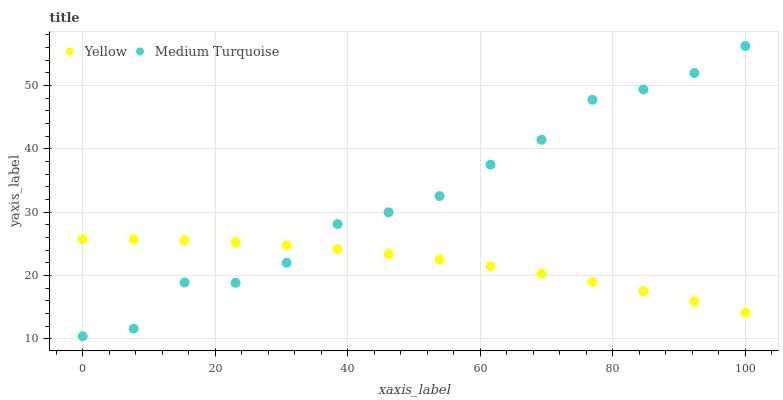Does Yellow have the minimum area under the curve?
Answer yes or no. Yes. Does Medium Turquoise have the maximum area under the curve?
Answer yes or no. Yes. Does Yellow have the maximum area under the curve?
Answer yes or no. No. Is Yellow the smoothest?
Answer yes or no. Yes. Is Medium Turquoise the roughest?
Answer yes or no. Yes. Is Yellow the roughest?
Answer yes or no. No. Does Medium Turquoise have the lowest value?
Answer yes or no. Yes. Does Yellow have the lowest value?
Answer yes or no. No. Does Medium Turquoise have the highest value?
Answer yes or no. Yes. Does Yellow have the highest value?
Answer yes or no. No. Does Medium Turquoise intersect Yellow?
Answer yes or no. Yes. Is Medium Turquoise less than Yellow?
Answer yes or no. No. Is Medium Turquoise greater than Yellow?
Answer yes or no. No. 